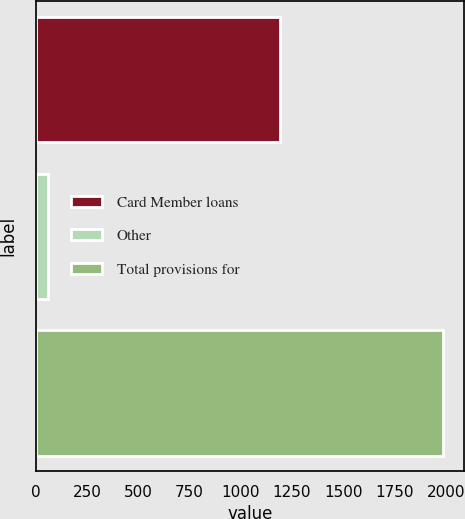<chart> <loc_0><loc_0><loc_500><loc_500><bar_chart><fcel>Card Member loans<fcel>Other<fcel>Total provisions for<nl><fcel>1190<fcel>61<fcel>1988<nl></chart> 